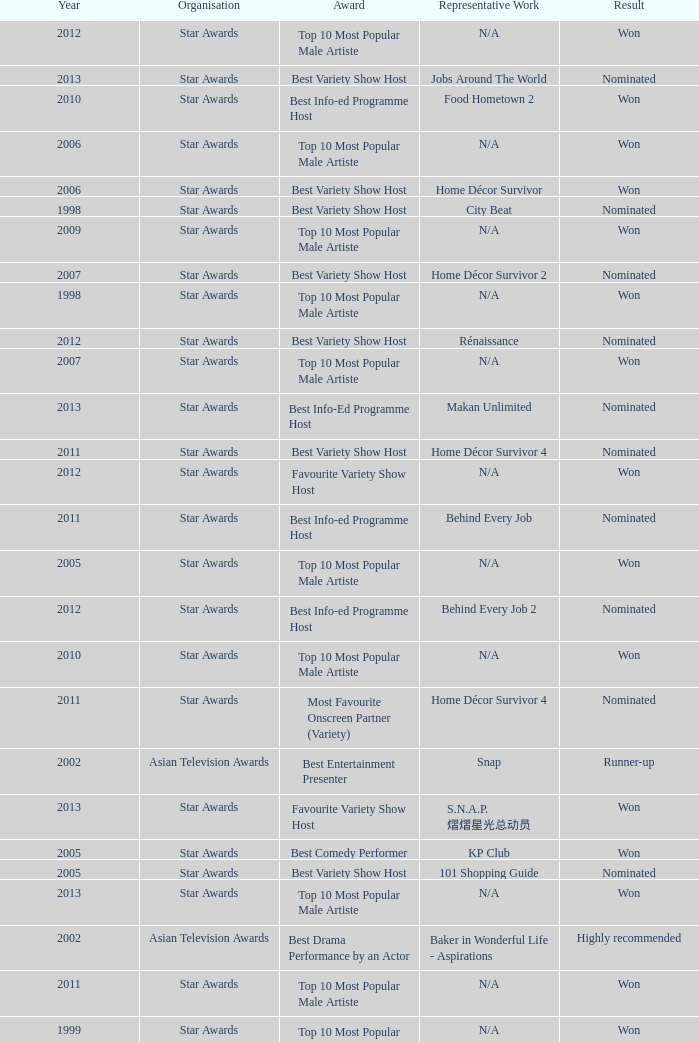What is the award for the Star Awards earlier than 2005 and the result is won? Top 10 Most Popular Male Artiste, Top 10 Most Popular Male Artiste. 